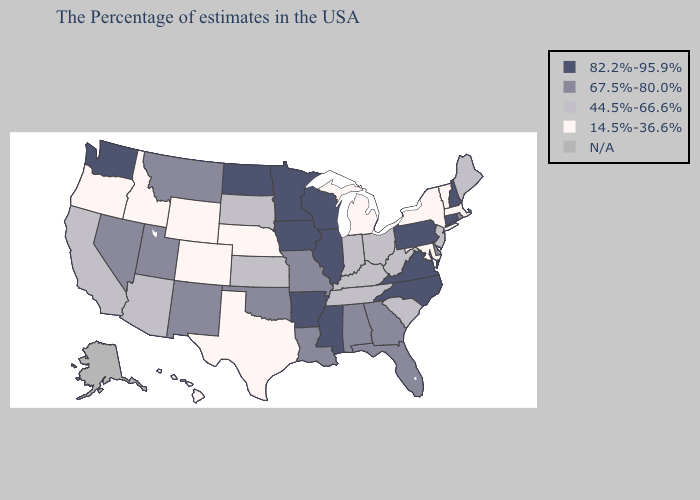Does Mississippi have the highest value in the South?
Quick response, please. Yes. Name the states that have a value in the range 14.5%-36.6%?
Keep it brief. Massachusetts, Vermont, New York, Maryland, Michigan, Nebraska, Texas, Wyoming, Colorado, Idaho, Oregon, Hawaii. Name the states that have a value in the range 14.5%-36.6%?
Be succinct. Massachusetts, Vermont, New York, Maryland, Michigan, Nebraska, Texas, Wyoming, Colorado, Idaho, Oregon, Hawaii. What is the value of Kentucky?
Concise answer only. 44.5%-66.6%. Which states hav the highest value in the MidWest?
Be succinct. Wisconsin, Illinois, Minnesota, Iowa, North Dakota. Which states have the highest value in the USA?
Concise answer only. New Hampshire, Connecticut, Pennsylvania, Virginia, North Carolina, Wisconsin, Illinois, Mississippi, Arkansas, Minnesota, Iowa, North Dakota, Washington. Does Connecticut have the highest value in the USA?
Answer briefly. Yes. Which states have the lowest value in the South?
Be succinct. Maryland, Texas. What is the lowest value in the MidWest?
Give a very brief answer. 14.5%-36.6%. What is the highest value in states that border Ohio?
Answer briefly. 82.2%-95.9%. What is the value of North Dakota?
Quick response, please. 82.2%-95.9%. Which states hav the highest value in the West?
Be succinct. Washington. Does Virginia have the highest value in the USA?
Short answer required. Yes. 